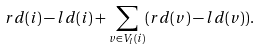Convert formula to latex. <formula><loc_0><loc_0><loc_500><loc_500>r d ( i ) - l d ( i ) + \sum _ { v \in V _ { l } ( i ) } ( r d ( v ) - l d ( v ) ) .</formula> 